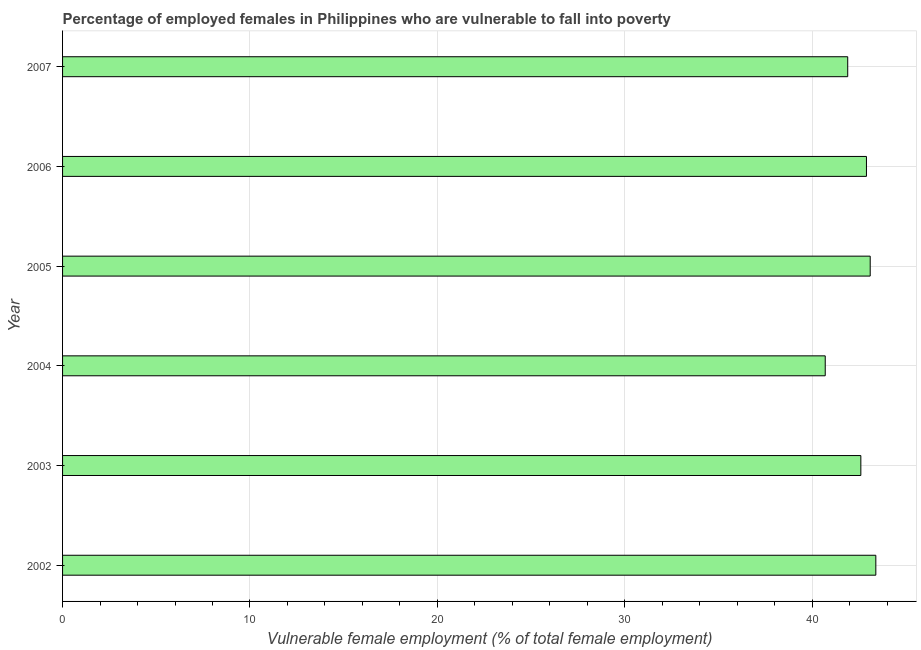Does the graph contain grids?
Make the answer very short. Yes. What is the title of the graph?
Ensure brevity in your answer.  Percentage of employed females in Philippines who are vulnerable to fall into poverty. What is the label or title of the X-axis?
Offer a very short reply. Vulnerable female employment (% of total female employment). What is the percentage of employed females who are vulnerable to fall into poverty in 2003?
Provide a short and direct response. 42.6. Across all years, what is the maximum percentage of employed females who are vulnerable to fall into poverty?
Offer a terse response. 43.4. Across all years, what is the minimum percentage of employed females who are vulnerable to fall into poverty?
Keep it short and to the point. 40.7. In which year was the percentage of employed females who are vulnerable to fall into poverty maximum?
Offer a very short reply. 2002. In which year was the percentage of employed females who are vulnerable to fall into poverty minimum?
Give a very brief answer. 2004. What is the sum of the percentage of employed females who are vulnerable to fall into poverty?
Provide a short and direct response. 254.6. What is the difference between the percentage of employed females who are vulnerable to fall into poverty in 2002 and 2007?
Ensure brevity in your answer.  1.5. What is the average percentage of employed females who are vulnerable to fall into poverty per year?
Your answer should be very brief. 42.43. What is the median percentage of employed females who are vulnerable to fall into poverty?
Offer a terse response. 42.75. In how many years, is the percentage of employed females who are vulnerable to fall into poverty greater than 4 %?
Provide a succinct answer. 6. What is the ratio of the percentage of employed females who are vulnerable to fall into poverty in 2004 to that in 2005?
Your answer should be compact. 0.94. Is the percentage of employed females who are vulnerable to fall into poverty in 2003 less than that in 2004?
Give a very brief answer. No. Is the difference between the percentage of employed females who are vulnerable to fall into poverty in 2003 and 2004 greater than the difference between any two years?
Your answer should be very brief. No. Is the sum of the percentage of employed females who are vulnerable to fall into poverty in 2002 and 2003 greater than the maximum percentage of employed females who are vulnerable to fall into poverty across all years?
Ensure brevity in your answer.  Yes. What is the difference between the highest and the lowest percentage of employed females who are vulnerable to fall into poverty?
Make the answer very short. 2.7. In how many years, is the percentage of employed females who are vulnerable to fall into poverty greater than the average percentage of employed females who are vulnerable to fall into poverty taken over all years?
Make the answer very short. 4. How many bars are there?
Your answer should be compact. 6. What is the Vulnerable female employment (% of total female employment) of 2002?
Your response must be concise. 43.4. What is the Vulnerable female employment (% of total female employment) of 2003?
Give a very brief answer. 42.6. What is the Vulnerable female employment (% of total female employment) in 2004?
Ensure brevity in your answer.  40.7. What is the Vulnerable female employment (% of total female employment) in 2005?
Offer a terse response. 43.1. What is the Vulnerable female employment (% of total female employment) of 2006?
Provide a succinct answer. 42.9. What is the Vulnerable female employment (% of total female employment) in 2007?
Your answer should be compact. 41.9. What is the difference between the Vulnerable female employment (% of total female employment) in 2002 and 2003?
Offer a terse response. 0.8. What is the difference between the Vulnerable female employment (% of total female employment) in 2002 and 2004?
Keep it short and to the point. 2.7. What is the difference between the Vulnerable female employment (% of total female employment) in 2002 and 2006?
Make the answer very short. 0.5. What is the difference between the Vulnerable female employment (% of total female employment) in 2002 and 2007?
Offer a very short reply. 1.5. What is the difference between the Vulnerable female employment (% of total female employment) in 2003 and 2004?
Your answer should be very brief. 1.9. What is the difference between the Vulnerable female employment (% of total female employment) in 2003 and 2007?
Give a very brief answer. 0.7. What is the difference between the Vulnerable female employment (% of total female employment) in 2004 and 2005?
Provide a succinct answer. -2.4. What is the difference between the Vulnerable female employment (% of total female employment) in 2005 and 2007?
Your answer should be very brief. 1.2. What is the ratio of the Vulnerable female employment (% of total female employment) in 2002 to that in 2004?
Your answer should be very brief. 1.07. What is the ratio of the Vulnerable female employment (% of total female employment) in 2002 to that in 2005?
Give a very brief answer. 1.01. What is the ratio of the Vulnerable female employment (% of total female employment) in 2002 to that in 2007?
Make the answer very short. 1.04. What is the ratio of the Vulnerable female employment (% of total female employment) in 2003 to that in 2004?
Your answer should be very brief. 1.05. What is the ratio of the Vulnerable female employment (% of total female employment) in 2003 to that in 2006?
Your answer should be compact. 0.99. What is the ratio of the Vulnerable female employment (% of total female employment) in 2003 to that in 2007?
Ensure brevity in your answer.  1.02. What is the ratio of the Vulnerable female employment (% of total female employment) in 2004 to that in 2005?
Offer a very short reply. 0.94. What is the ratio of the Vulnerable female employment (% of total female employment) in 2004 to that in 2006?
Give a very brief answer. 0.95. What is the ratio of the Vulnerable female employment (% of total female employment) in 2004 to that in 2007?
Your response must be concise. 0.97. What is the ratio of the Vulnerable female employment (% of total female employment) in 2005 to that in 2006?
Your answer should be very brief. 1. What is the ratio of the Vulnerable female employment (% of total female employment) in 2005 to that in 2007?
Keep it short and to the point. 1.03. 